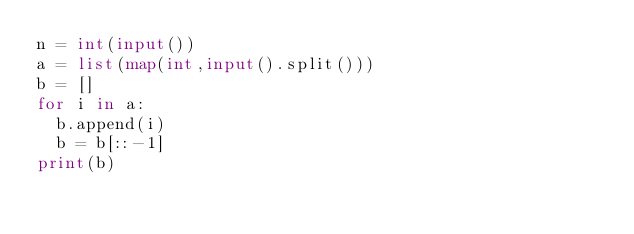Convert code to text. <code><loc_0><loc_0><loc_500><loc_500><_Python_>n = int(input())
a = list(map(int,input().split()))
b = []
for i in a:
  b.append(i)
  b = b[::-1]
print(b)</code> 